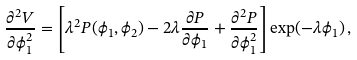Convert formula to latex. <formula><loc_0><loc_0><loc_500><loc_500>\frac { \partial ^ { 2 } V } { \partial \phi _ { 1 } ^ { 2 } } = \left [ \lambda ^ { 2 } P ( \phi _ { 1 } , \phi _ { 2 } ) - 2 \lambda \frac { \partial P } { \partial \phi _ { 1 } } + \frac { \partial ^ { 2 } P } { \partial \phi _ { 1 } ^ { 2 } } \right ] \exp ( - \lambda \phi _ { 1 } ) \, ,</formula> 